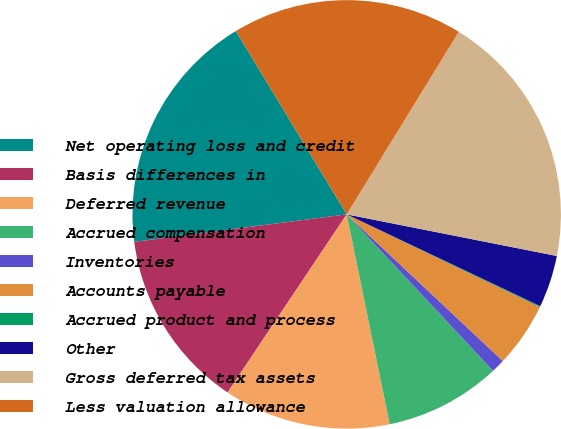<chart> <loc_0><loc_0><loc_500><loc_500><pie_chart><fcel>Net operating loss and credit<fcel>Basis differences in<fcel>Deferred revenue<fcel>Accrued compensation<fcel>Inventories<fcel>Accounts payable<fcel>Accrued product and process<fcel>Other<fcel>Gross deferred tax assets<fcel>Less valuation allowance<nl><fcel>18.39%<fcel>13.57%<fcel>12.6%<fcel>8.75%<fcel>1.03%<fcel>4.89%<fcel>0.07%<fcel>3.93%<fcel>19.35%<fcel>17.42%<nl></chart> 